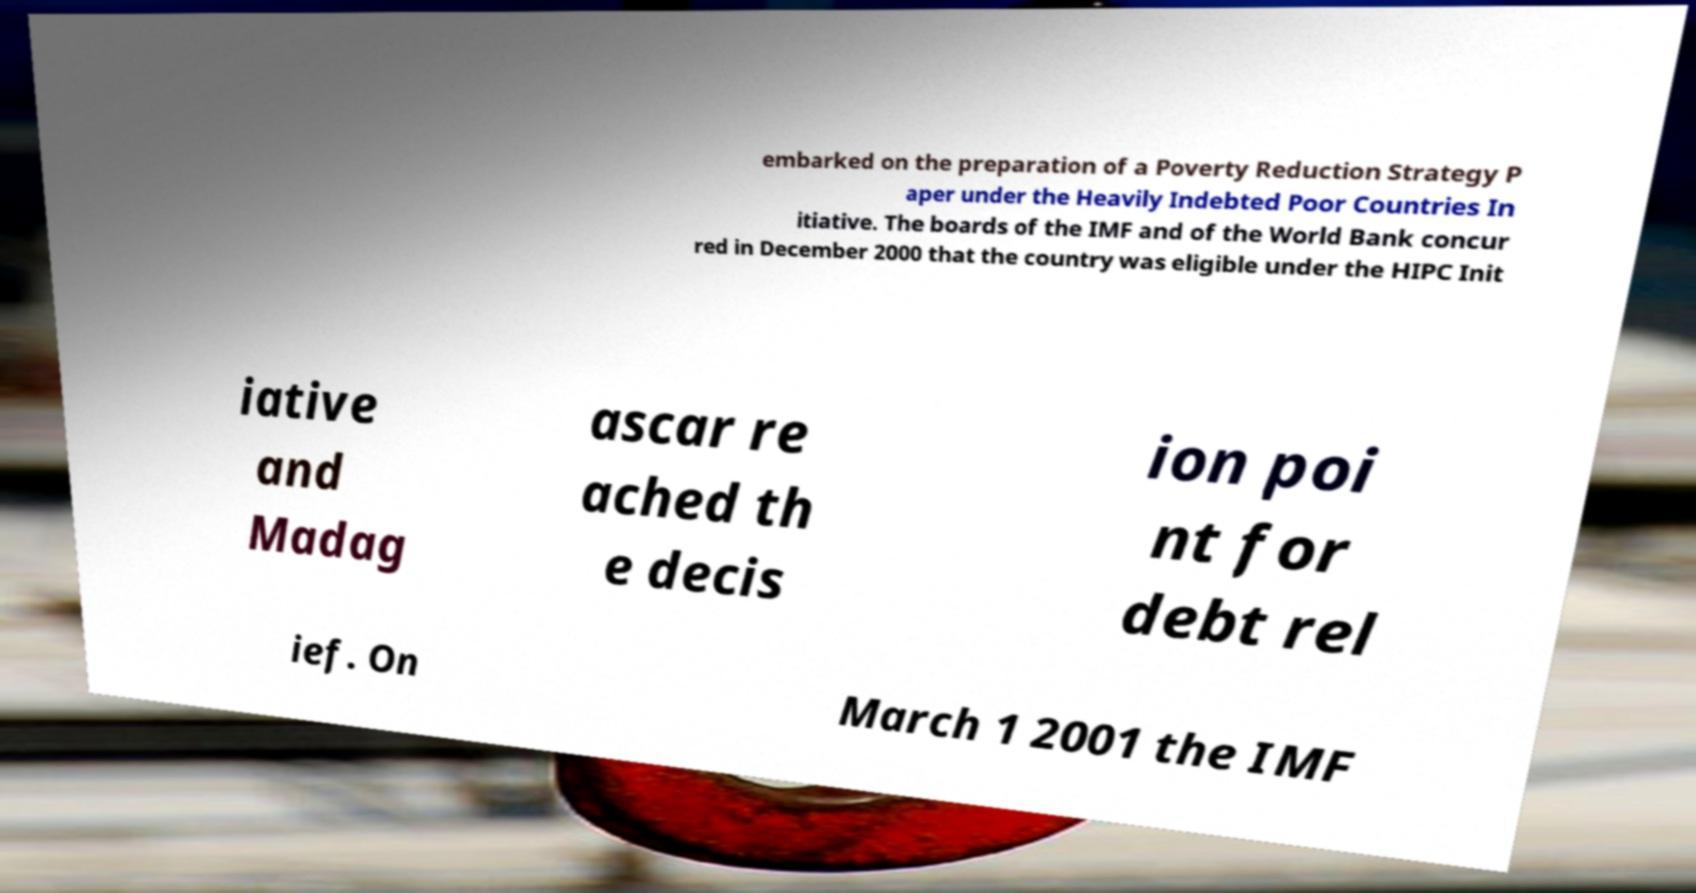Please identify and transcribe the text found in this image. embarked on the preparation of a Poverty Reduction Strategy P aper under the Heavily Indebted Poor Countries In itiative. The boards of the IMF and of the World Bank concur red in December 2000 that the country was eligible under the HIPC Init iative and Madag ascar re ached th e decis ion poi nt for debt rel ief. On March 1 2001 the IMF 